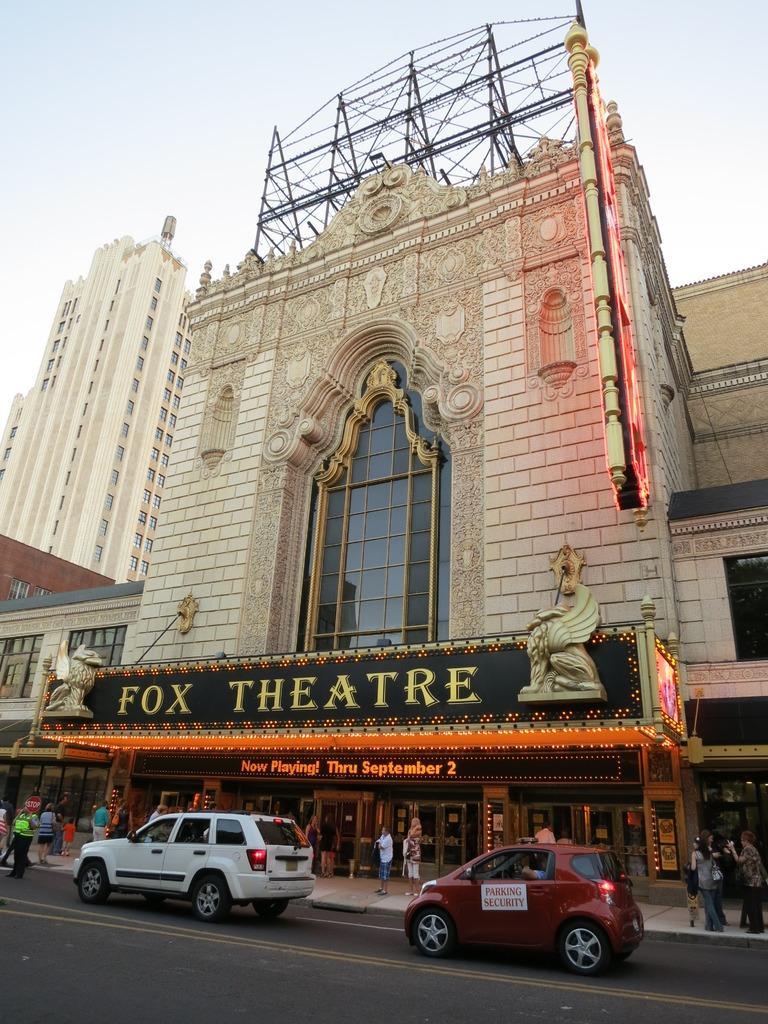How would you summarize this image in a sentence or two? To the bottom of the image there is a road. On the road there is a white color car and behind that there is a red color car. Beside the cars there is a footpath with few people are walking on it. In the middle of the image there is a building with name board on it. And also there are many buildings and trees. To the top of the image there is a sky. 